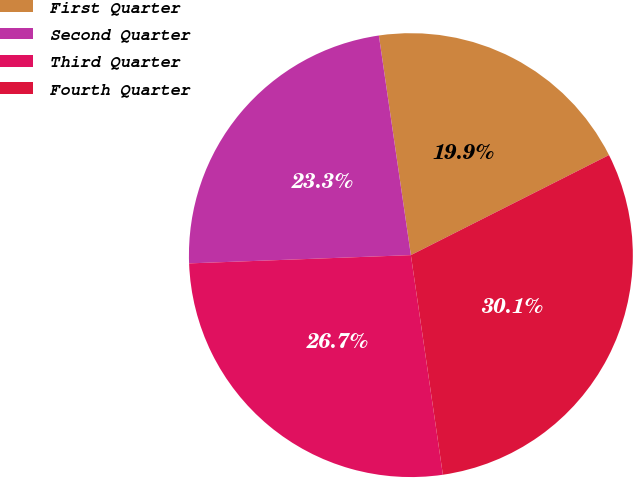Convert chart. <chart><loc_0><loc_0><loc_500><loc_500><pie_chart><fcel>First Quarter<fcel>Second Quarter<fcel>Third Quarter<fcel>Fourth Quarter<nl><fcel>19.86%<fcel>23.29%<fcel>26.71%<fcel>30.14%<nl></chart> 